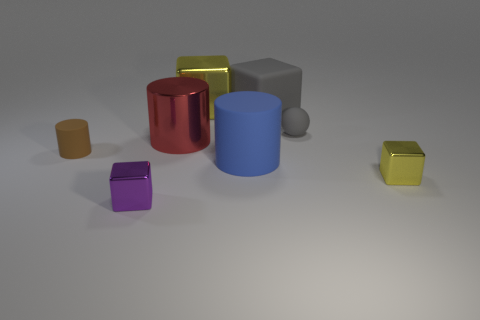Is there a thing of the same color as the ball?
Keep it short and to the point. Yes. Are there fewer purple rubber cubes than tiny cubes?
Give a very brief answer. Yes. What number of objects are either red objects or objects that are to the left of the tiny yellow metallic thing?
Make the answer very short. 7. Are there any gray things that have the same material as the tiny purple cube?
Make the answer very short. No. What material is the brown cylinder that is the same size as the sphere?
Ensure brevity in your answer.  Rubber. There is a large cube in front of the yellow cube left of the big gray cube; what is its material?
Ensure brevity in your answer.  Rubber. Is the shape of the large metal thing on the left side of the big yellow thing the same as  the big gray thing?
Provide a short and direct response. No. What is the color of the tiny cylinder that is the same material as the blue object?
Give a very brief answer. Brown. There is a big cube on the right side of the big yellow shiny cube; what material is it?
Make the answer very short. Rubber. There is a tiny purple metallic object; is it the same shape as the large shiny thing that is to the left of the big yellow thing?
Offer a terse response. No. 